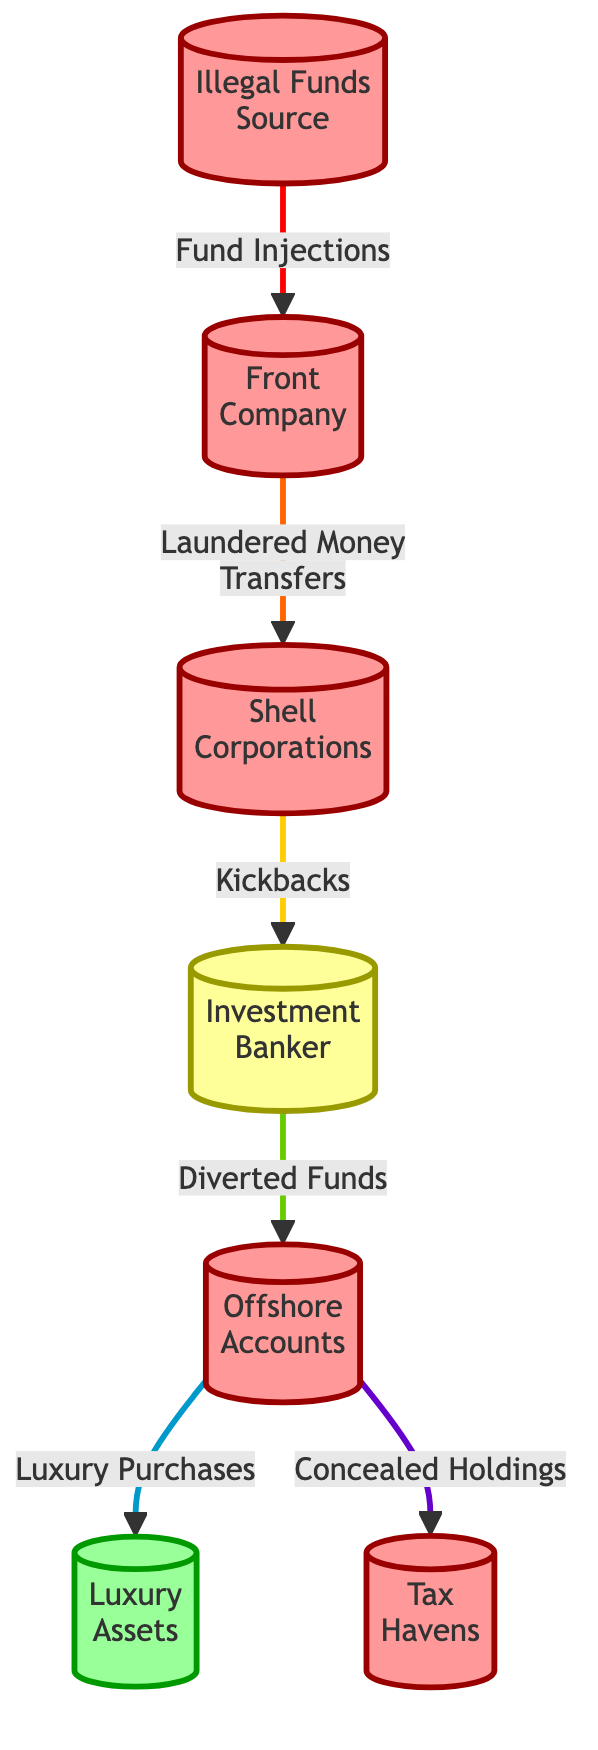What is the source of illegal funds? The first node in the diagram, which is labeled "Illegal Funds Source," explicitly indicates the origin of illicit finances in this flow.
Answer: Illegal Funds Source How many total nodes are present in the diagram? By counting all the circles (nodes) involved, there are seven distinct nodes depicted in the flowchart.
Answer: 7 What type of node is the "Investment Banker"? The "Investment Banker" node is highlighted with a specific class designation which shows it as a bankerNode, indicating its role within the illicit fund flow chain.
Answer: bankerNode What flows into the "Shell Corporations" node? The diagram indicates that a flow of "Laundered Money Transfers" from the "Front Company" leads into the "Shell Corporations" node, specifying the type of interaction.
Answer: Laundered Money Transfers Which node receives "Kickbacks" from the "Shell Corporations"? The "Investment Banker" node receives the "Kickbacks" as shown by the direct connection from the "Shell Corporations" node, indicating a flow of illegal profits.
Answer: Investment Banker Which node is connected to both "Luxury Purchases" and "Concealed Holdings"? The "Offshore Accounts" node has outgoing flows directed towards both "Luxury Assets" and "Tax Havens," highlighting its critical role in the distribution of illicit funds.
Answer: Offshore Accounts What is the last node in the flowchart? The farthest downstream nodes are "Luxury Assets" and "Tax Havens," which terminate the flow of money, indicating where the illicit funds are ultimately funneled.
Answer: Luxury Assets and Tax Havens How many illegal nodes are there in total? The nodes labeled as illegal (illegalNode) include "Illegal Funds Source," "Front Company," "Shell Corporations," "Offshore Accounts," and "Tax Havens," leading to a count of five illegal nodes.
Answer: 5 In what manner are "Luxury Assets" related to "Offshore Accounts"? The "Luxury Assets" receive a flow labeled "Luxury Purchases," illustrating how funds are utilized after passing through the "Offshore Accounts."
Answer: Luxury Purchases 